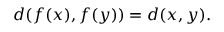<formula> <loc_0><loc_0><loc_500><loc_500>d ( f ( x ) , f ( y ) ) = d ( x , y ) .</formula> 